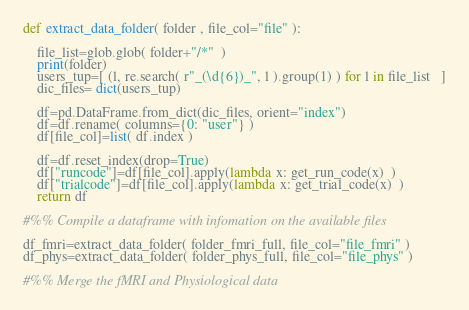Convert code to text. <code><loc_0><loc_0><loc_500><loc_500><_Python_>def extract_data_folder( folder , file_col="file" ):
    
    file_list=glob.glob( folder+"/*"  )
    print(folder)
    users_tup=[ (l, re.search( r"_(\d{6})_", l ).group(1) ) for l in file_list   ]
    dic_files= dict(users_tup) 
    
    df=pd.DataFrame.from_dict(dic_files, orient="index")
    df=df.rename( columns={0: "user"} )
    df[file_col]=list( df.index )
    
    df=df.reset_index(drop=True)       
    df["runcode"]=df[file_col].apply(lambda x: get_run_code(x)  )
    df["trialcode"]=df[file_col].apply(lambda x: get_trial_code(x)  )
    return df

#%% Compile a dataframe with infomation on the available files 

df_fmri=extract_data_folder( folder_fmri_full, file_col="file_fmri" )
df_phys=extract_data_folder( folder_phys_full, file_col="file_phys" )

#%% Merge the fMRI and Physiological data </code> 